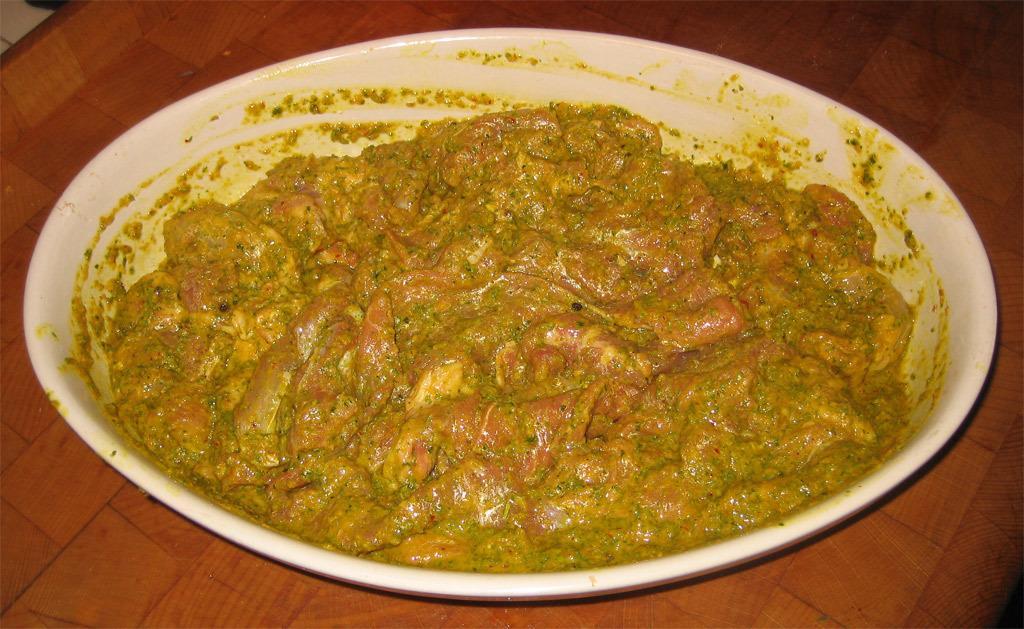In one or two sentences, can you explain what this image depicts? In this image there is a food item in a white color bowl , on the table. 